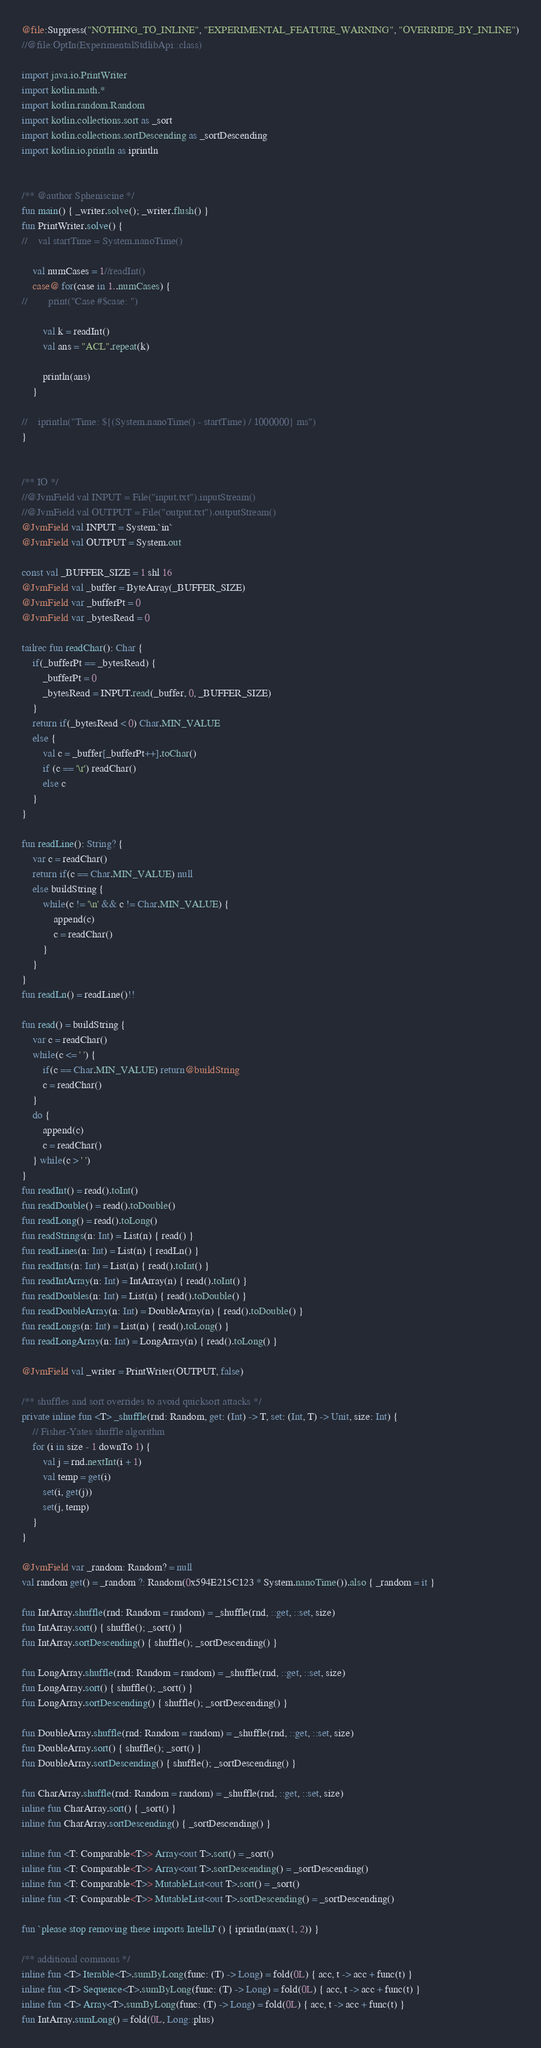<code> <loc_0><loc_0><loc_500><loc_500><_Kotlin_>@file:Suppress("NOTHING_TO_INLINE", "EXPERIMENTAL_FEATURE_WARNING", "OVERRIDE_BY_INLINE")
//@file:OptIn(ExperimentalStdlibApi::class)

import java.io.PrintWriter
import kotlin.math.*
import kotlin.random.Random
import kotlin.collections.sort as _sort
import kotlin.collections.sortDescending as _sortDescending
import kotlin.io.println as iprintln


/** @author Spheniscine */
fun main() { _writer.solve(); _writer.flush() }
fun PrintWriter.solve() {
//    val startTime = System.nanoTime()

    val numCases = 1//readInt()
    case@ for(case in 1..numCases) {
//        print("Case #$case: ")

        val k = readInt()
        val ans = "ACL".repeat(k)

        println(ans)
    }

//    iprintln("Time: ${(System.nanoTime() - startTime) / 1000000} ms")
}


/** IO */
//@JvmField val INPUT = File("input.txt").inputStream()
//@JvmField val OUTPUT = File("output.txt").outputStream()
@JvmField val INPUT = System.`in`
@JvmField val OUTPUT = System.out

const val _BUFFER_SIZE = 1 shl 16
@JvmField val _buffer = ByteArray(_BUFFER_SIZE)
@JvmField var _bufferPt = 0
@JvmField var _bytesRead = 0

tailrec fun readChar(): Char {
    if(_bufferPt == _bytesRead) {
        _bufferPt = 0
        _bytesRead = INPUT.read(_buffer, 0, _BUFFER_SIZE)
    }
    return if(_bytesRead < 0) Char.MIN_VALUE
    else {
        val c = _buffer[_bufferPt++].toChar()
        if (c == '\r') readChar()
        else c
    }
}

fun readLine(): String? {
    var c = readChar()
    return if(c == Char.MIN_VALUE) null
    else buildString {
        while(c != '\n' && c != Char.MIN_VALUE) {
            append(c)
            c = readChar()
        }
    }
}
fun readLn() = readLine()!!

fun read() = buildString {
    var c = readChar()
    while(c <= ' ') {
        if(c == Char.MIN_VALUE) return@buildString
        c = readChar()
    }
    do {
        append(c)
        c = readChar()
    } while(c > ' ')
}
fun readInt() = read().toInt()
fun readDouble() = read().toDouble()
fun readLong() = read().toLong()
fun readStrings(n: Int) = List(n) { read() }
fun readLines(n: Int) = List(n) { readLn() }
fun readInts(n: Int) = List(n) { read().toInt() }
fun readIntArray(n: Int) = IntArray(n) { read().toInt() }
fun readDoubles(n: Int) = List(n) { read().toDouble() }
fun readDoubleArray(n: Int) = DoubleArray(n) { read().toDouble() }
fun readLongs(n: Int) = List(n) { read().toLong() }
fun readLongArray(n: Int) = LongArray(n) { read().toLong() }

@JvmField val _writer = PrintWriter(OUTPUT, false)

/** shuffles and sort overrides to avoid quicksort attacks */
private inline fun <T> _shuffle(rnd: Random, get: (Int) -> T, set: (Int, T) -> Unit, size: Int) {
    // Fisher-Yates shuffle algorithm
    for (i in size - 1 downTo 1) {
        val j = rnd.nextInt(i + 1)
        val temp = get(i)
        set(i, get(j))
        set(j, temp)
    }
}

@JvmField var _random: Random? = null
val random get() = _random ?: Random(0x594E215C123 * System.nanoTime()).also { _random = it }

fun IntArray.shuffle(rnd: Random = random) = _shuffle(rnd, ::get, ::set, size)
fun IntArray.sort() { shuffle(); _sort() }
fun IntArray.sortDescending() { shuffle(); _sortDescending() }

fun LongArray.shuffle(rnd: Random = random) = _shuffle(rnd, ::get, ::set, size)
fun LongArray.sort() { shuffle(); _sort() }
fun LongArray.sortDescending() { shuffle(); _sortDescending() }

fun DoubleArray.shuffle(rnd: Random = random) = _shuffle(rnd, ::get, ::set, size)
fun DoubleArray.sort() { shuffle(); _sort() }
fun DoubleArray.sortDescending() { shuffle(); _sortDescending() }

fun CharArray.shuffle(rnd: Random = random) = _shuffle(rnd, ::get, ::set, size)
inline fun CharArray.sort() { _sort() }
inline fun CharArray.sortDescending() { _sortDescending() }

inline fun <T: Comparable<T>> Array<out T>.sort() = _sort()
inline fun <T: Comparable<T>> Array<out T>.sortDescending() = _sortDescending()
inline fun <T: Comparable<T>> MutableList<out T>.sort() = _sort()
inline fun <T: Comparable<T>> MutableList<out T>.sortDescending() = _sortDescending()

fun `please stop removing these imports IntelliJ`() { iprintln(max(1, 2)) }

/** additional commons */
inline fun <T> Iterable<T>.sumByLong(func: (T) -> Long) = fold(0L) { acc, t -> acc + func(t) }
inline fun <T> Sequence<T>.sumByLong(func: (T) -> Long) = fold(0L) { acc, t -> acc + func(t) }
inline fun <T> Array<T>.sumByLong(func: (T) -> Long) = fold(0L) { acc, t -> acc + func(t) }
fun IntArray.sumLong() = fold(0L, Long::plus)
</code> 